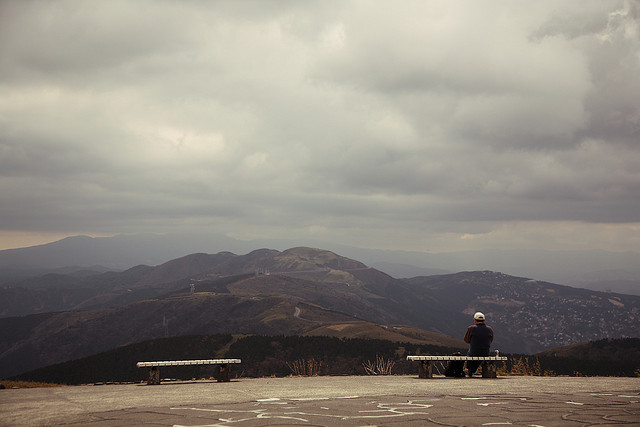<image>What is the photographer standing between? It is unknown what the photographer is standing between. The options could be between benches or mountains. What is the photographer standing between? I don't know what the photographer is standing between. It can be between benches and mountains, or just benches. 